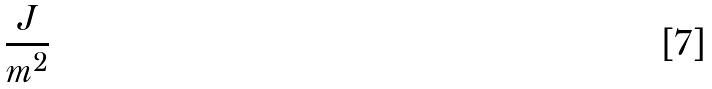<formula> <loc_0><loc_0><loc_500><loc_500>\frac { J } { m ^ { 2 } }</formula> 